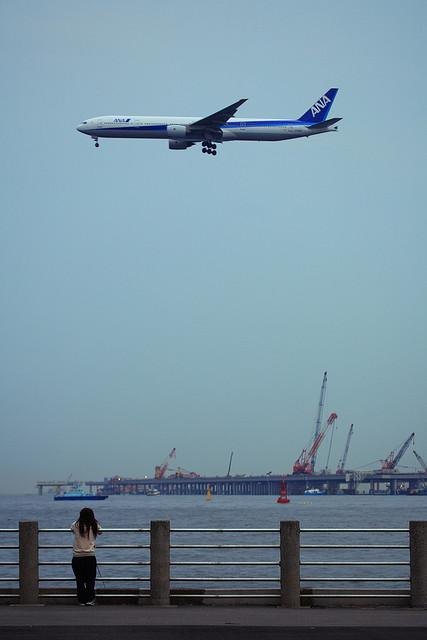From what country does ANA hail from?

Choices:
A) sweden
B) japan
C) norway
D) france japan 